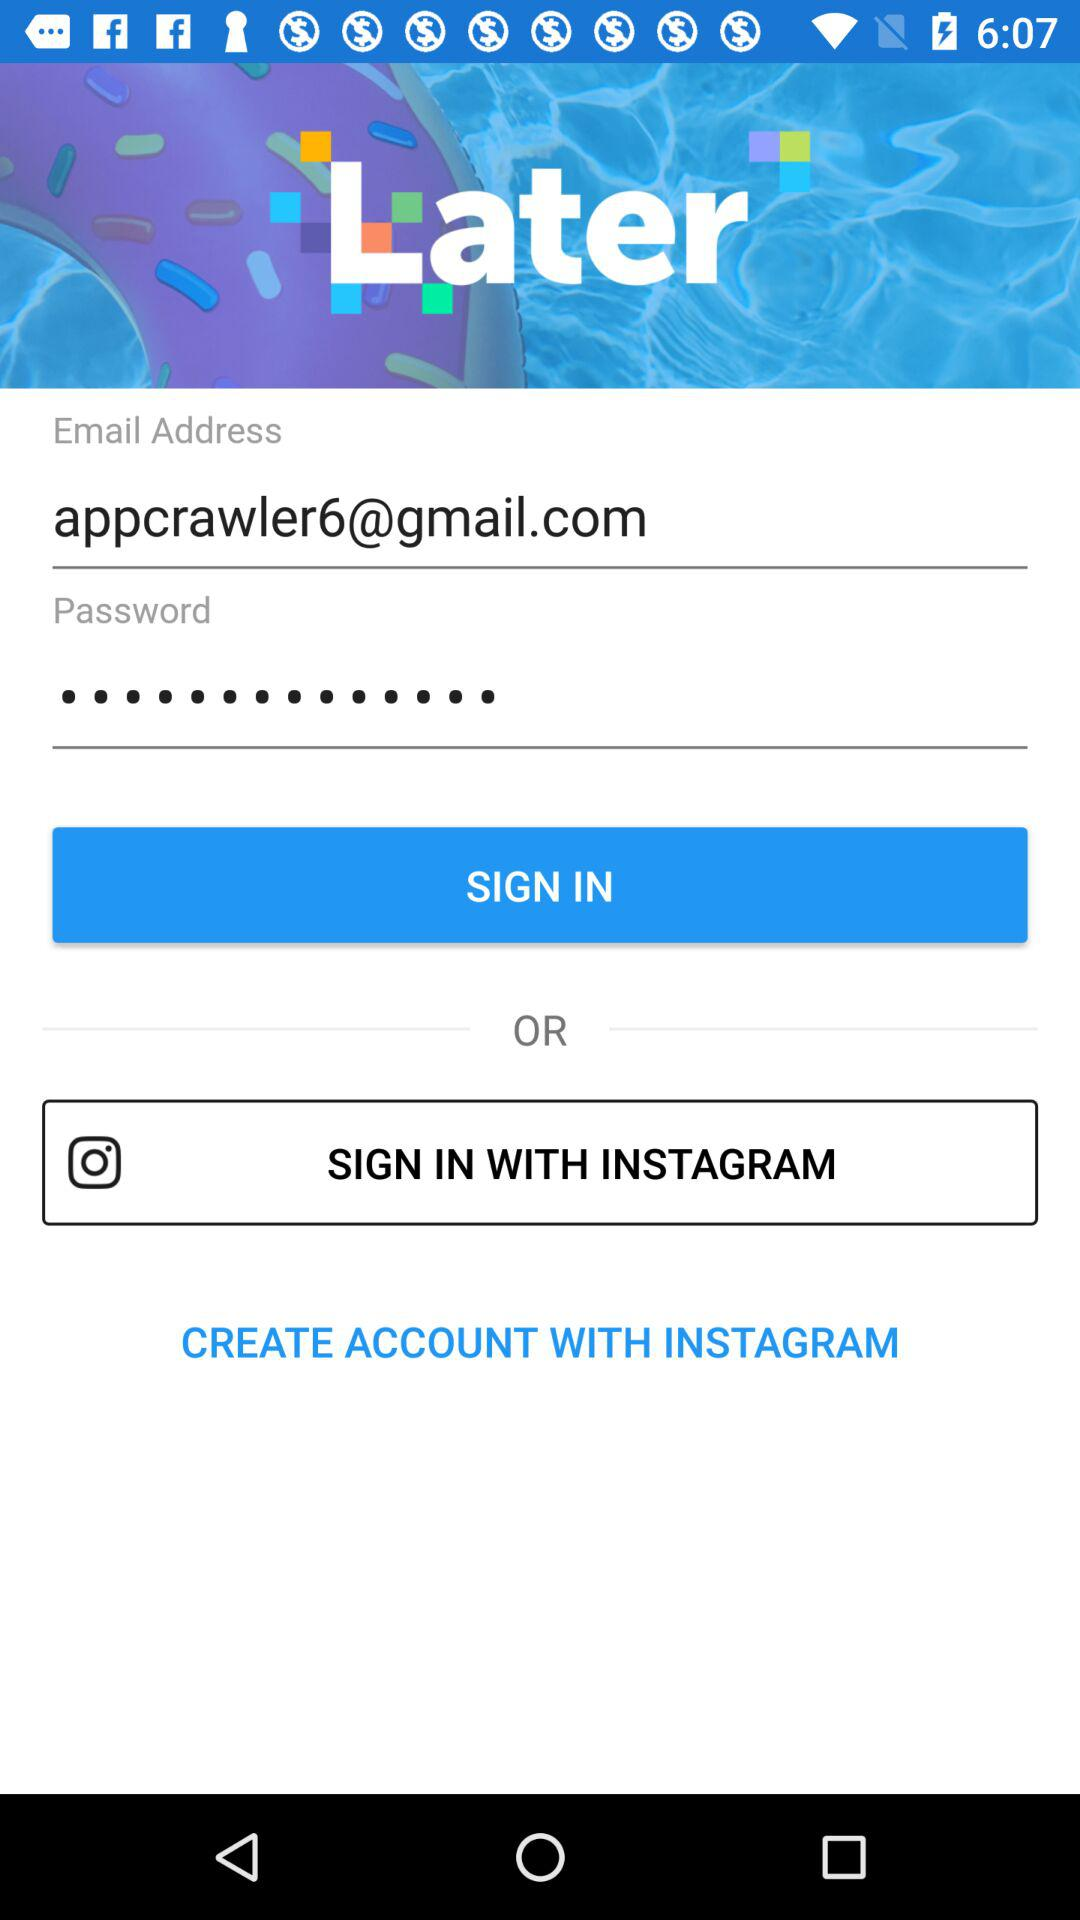Which accounts can I use to sign in? You can use "Email" and "INSTAGRAM" accounts to sign in. 